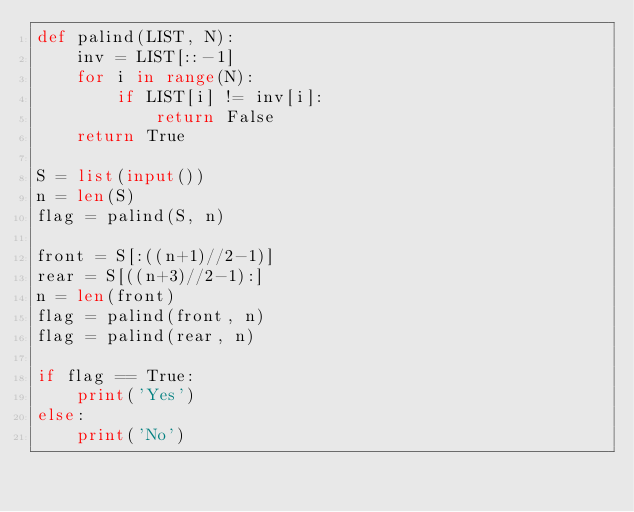<code> <loc_0><loc_0><loc_500><loc_500><_Python_>def palind(LIST, N):
    inv = LIST[::-1]
    for i in range(N):
        if LIST[i] != inv[i]:
            return False
    return True

S = list(input())
n = len(S)
flag = palind(S, n)

front = S[:((n+1)//2-1)]
rear = S[((n+3)//2-1):]
n = len(front)
flag = palind(front, n)
flag = palind(rear, n)

if flag == True:
    print('Yes')
else:
    print('No')</code> 